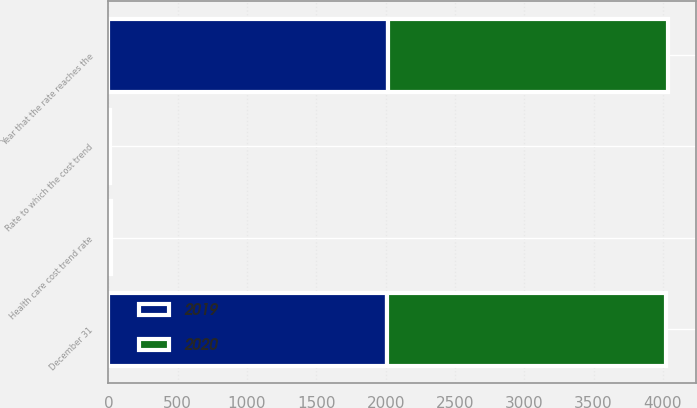Convert chart to OTSL. <chart><loc_0><loc_0><loc_500><loc_500><stacked_bar_chart><ecel><fcel>December 31<fcel>Health care cost trend rate<fcel>Rate to which the cost trend<fcel>Year that the rate reaches the<nl><fcel>2019<fcel>2013<fcel>8<fcel>5<fcel>2020<nl><fcel>2020<fcel>2012<fcel>8<fcel>5<fcel>2019<nl></chart> 